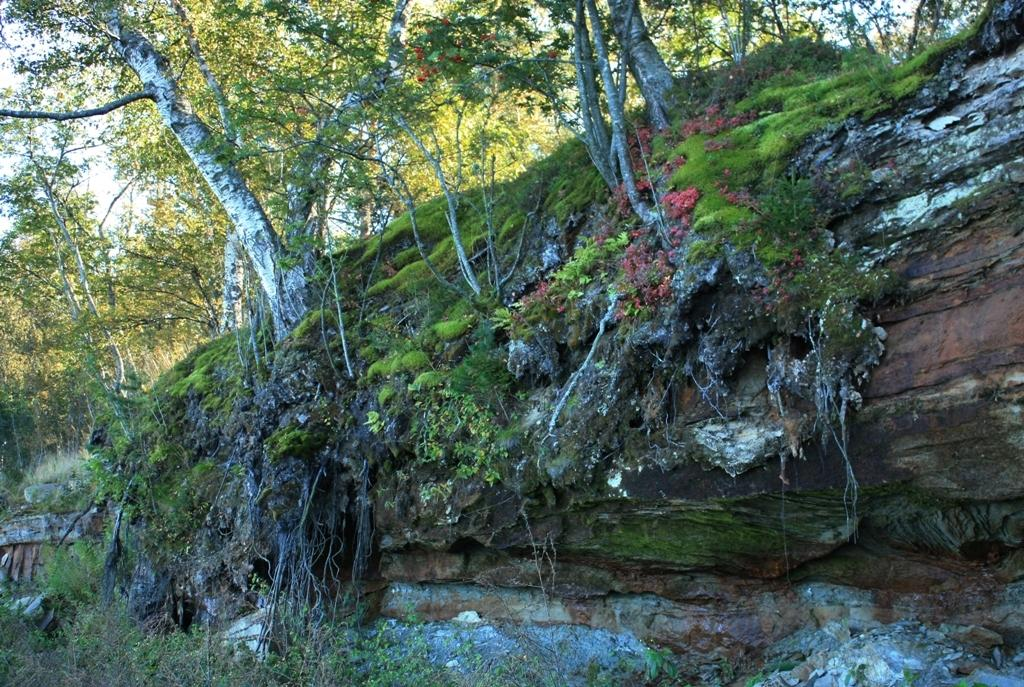What type of vegetation can be seen in the image? There are trees in the image. Where are the trees located? The trees are on a hill. How many giraffes can be seen grazing on the property in the image? There are no giraffes present in the image; it only features trees on a hill. 